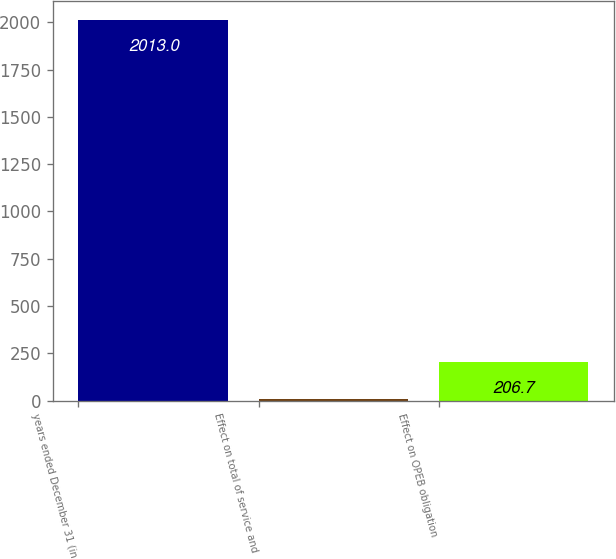Convert chart to OTSL. <chart><loc_0><loc_0><loc_500><loc_500><bar_chart><fcel>years ended December 31 (in<fcel>Effect on total of service and<fcel>Effect on OPEB obligation<nl><fcel>2013<fcel>6<fcel>206.7<nl></chart> 